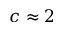<formula> <loc_0><loc_0><loc_500><loc_500>c \approx 2</formula> 